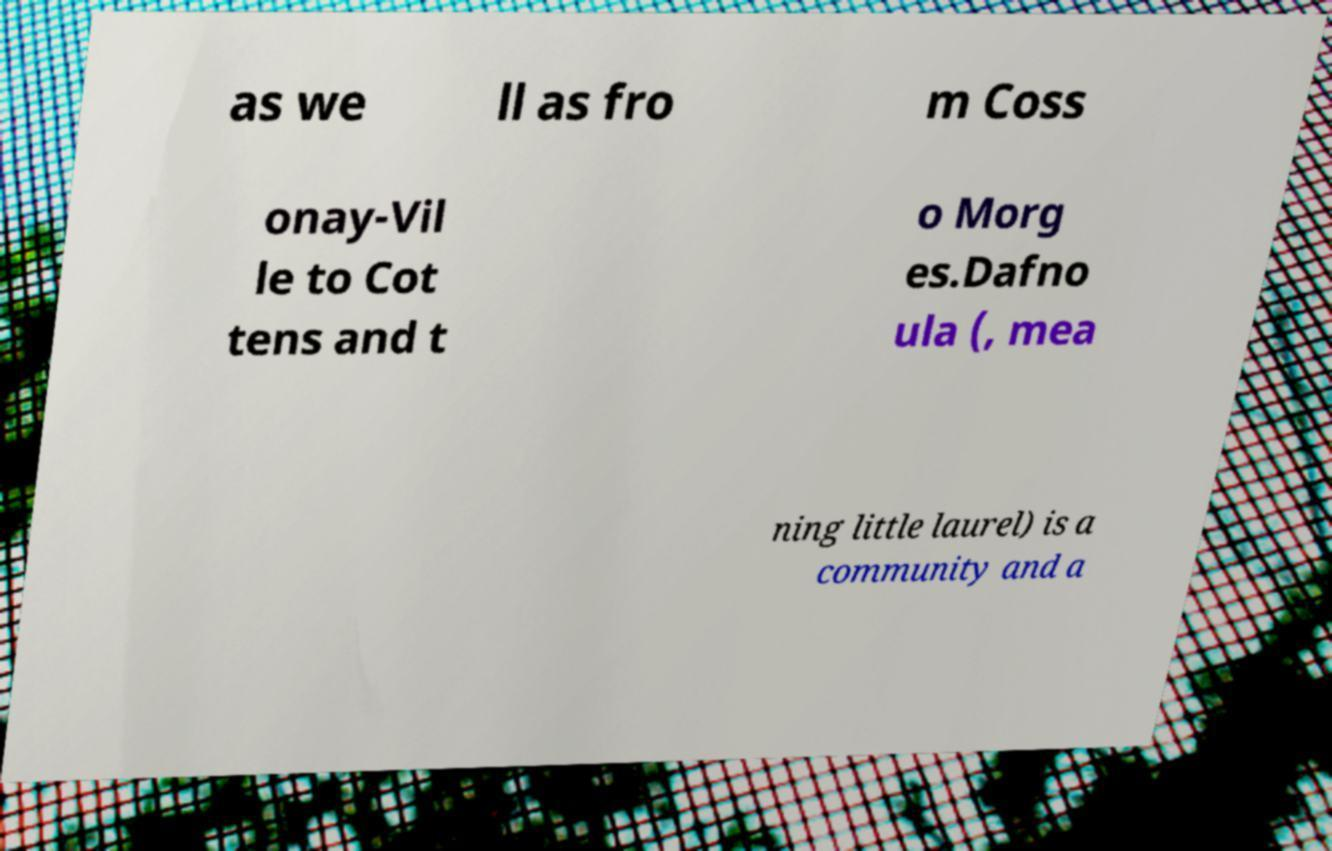There's text embedded in this image that I need extracted. Can you transcribe it verbatim? as we ll as fro m Coss onay-Vil le to Cot tens and t o Morg es.Dafno ula (, mea ning little laurel) is a community and a 